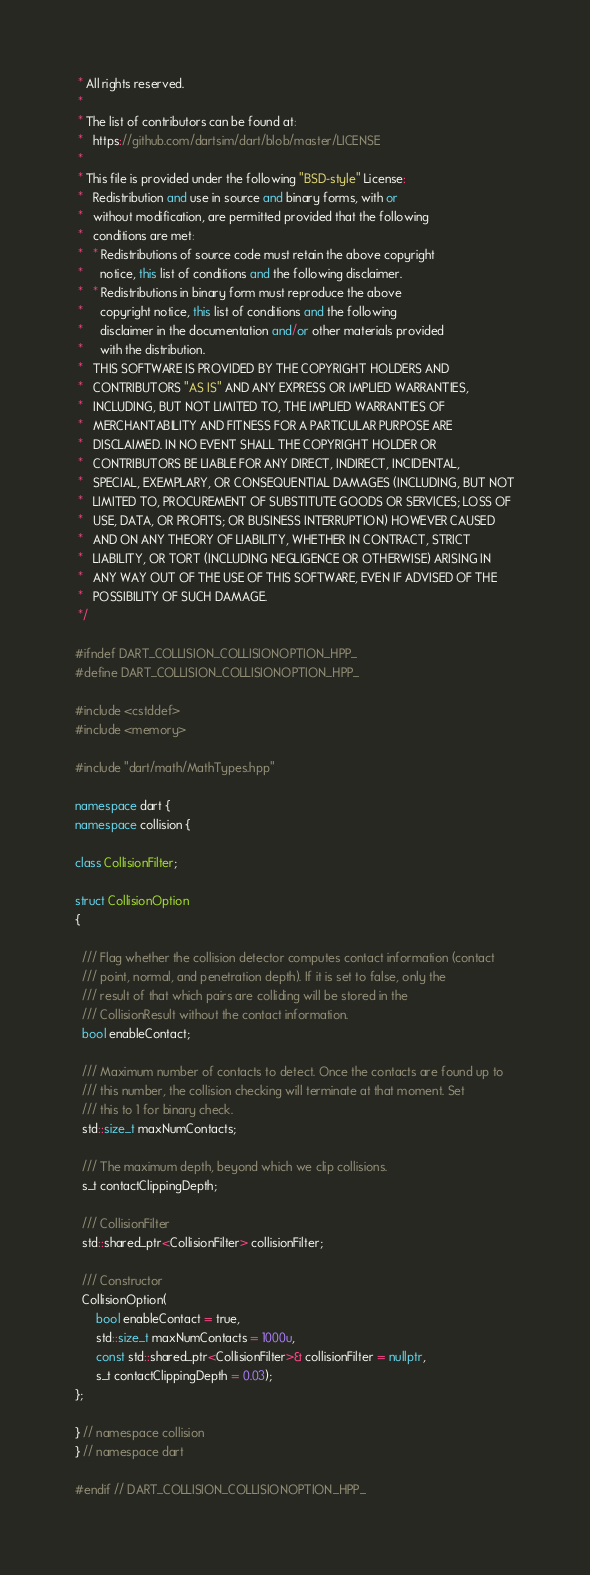Convert code to text. <code><loc_0><loc_0><loc_500><loc_500><_C++_> * All rights reserved.
 *
 * The list of contributors can be found at:
 *   https://github.com/dartsim/dart/blob/master/LICENSE
 *
 * This file is provided under the following "BSD-style" License:
 *   Redistribution and use in source and binary forms, with or
 *   without modification, are permitted provided that the following
 *   conditions are met:
 *   * Redistributions of source code must retain the above copyright
 *     notice, this list of conditions and the following disclaimer.
 *   * Redistributions in binary form must reproduce the above
 *     copyright notice, this list of conditions and the following
 *     disclaimer in the documentation and/or other materials provided
 *     with the distribution.
 *   THIS SOFTWARE IS PROVIDED BY THE COPYRIGHT HOLDERS AND
 *   CONTRIBUTORS "AS IS" AND ANY EXPRESS OR IMPLIED WARRANTIES,
 *   INCLUDING, BUT NOT LIMITED TO, THE IMPLIED WARRANTIES OF
 *   MERCHANTABILITY AND FITNESS FOR A PARTICULAR PURPOSE ARE
 *   DISCLAIMED. IN NO EVENT SHALL THE COPYRIGHT HOLDER OR
 *   CONTRIBUTORS BE LIABLE FOR ANY DIRECT, INDIRECT, INCIDENTAL,
 *   SPECIAL, EXEMPLARY, OR CONSEQUENTIAL DAMAGES (INCLUDING, BUT NOT
 *   LIMITED TO, PROCUREMENT OF SUBSTITUTE GOODS OR SERVICES; LOSS OF
 *   USE, DATA, OR PROFITS; OR BUSINESS INTERRUPTION) HOWEVER CAUSED
 *   AND ON ANY THEORY OF LIABILITY, WHETHER IN CONTRACT, STRICT
 *   LIABILITY, OR TORT (INCLUDING NEGLIGENCE OR OTHERWISE) ARISING IN
 *   ANY WAY OUT OF THE USE OF THIS SOFTWARE, EVEN IF ADVISED OF THE
 *   POSSIBILITY OF SUCH DAMAGE.
 */

#ifndef DART_COLLISION_COLLISIONOPTION_HPP_
#define DART_COLLISION_COLLISIONOPTION_HPP_

#include <cstddef>
#include <memory>

#include "dart/math/MathTypes.hpp"

namespace dart {
namespace collision {

class CollisionFilter;

struct CollisionOption
{

  /// Flag whether the collision detector computes contact information (contact
  /// point, normal, and penetration depth). If it is set to false, only the
  /// result of that which pairs are colliding will be stored in the
  /// CollisionResult without the contact information.
  bool enableContact;

  /// Maximum number of contacts to detect. Once the contacts are found up to
  /// this number, the collision checking will terminate at that moment. Set
  /// this to 1 for binary check.
  std::size_t maxNumContacts;

  /// The maximum depth, beyond which we clip collisions.
  s_t contactClippingDepth;

  /// CollisionFilter
  std::shared_ptr<CollisionFilter> collisionFilter;

  /// Constructor
  CollisionOption(
      bool enableContact = true,
      std::size_t maxNumContacts = 1000u,
      const std::shared_ptr<CollisionFilter>& collisionFilter = nullptr,
      s_t contactClippingDepth = 0.03);
};

} // namespace collision
} // namespace dart

#endif // DART_COLLISION_COLLISIONOPTION_HPP_
</code> 